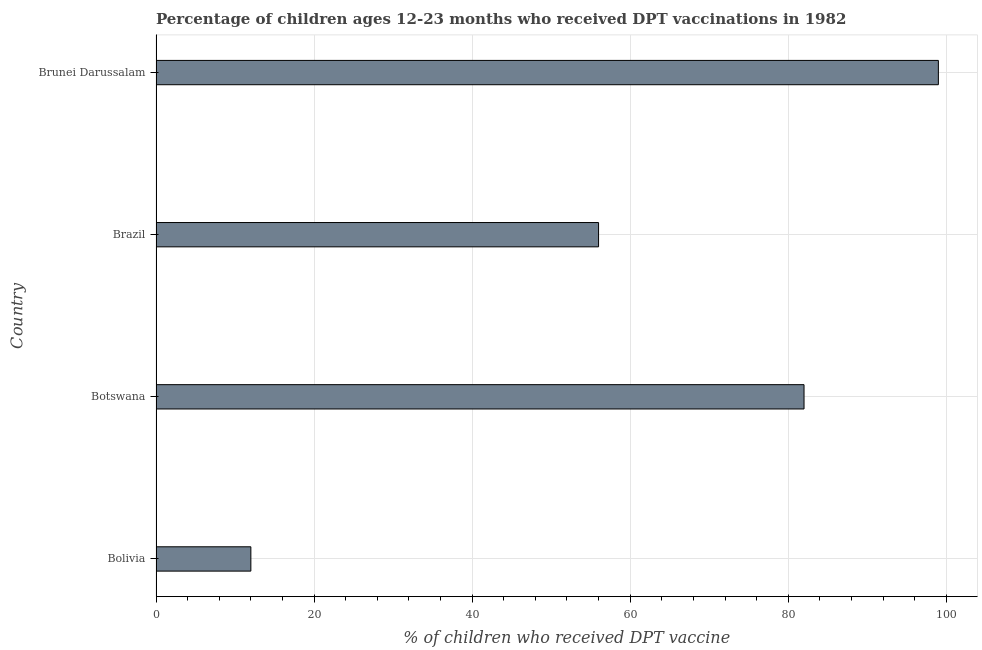What is the title of the graph?
Your response must be concise. Percentage of children ages 12-23 months who received DPT vaccinations in 1982. What is the label or title of the X-axis?
Your answer should be compact. % of children who received DPT vaccine. What is the label or title of the Y-axis?
Provide a succinct answer. Country. In which country was the percentage of children who received dpt vaccine maximum?
Give a very brief answer. Brunei Darussalam. In which country was the percentage of children who received dpt vaccine minimum?
Offer a very short reply. Bolivia. What is the sum of the percentage of children who received dpt vaccine?
Provide a short and direct response. 249. What is the average percentage of children who received dpt vaccine per country?
Keep it short and to the point. 62.25. What is the ratio of the percentage of children who received dpt vaccine in Botswana to that in Brunei Darussalam?
Offer a terse response. 0.83. Is the percentage of children who received dpt vaccine in Bolivia less than that in Brunei Darussalam?
Provide a short and direct response. Yes. Is the difference between the percentage of children who received dpt vaccine in Botswana and Brazil greater than the difference between any two countries?
Provide a succinct answer. No. Is the sum of the percentage of children who received dpt vaccine in Bolivia and Brazil greater than the maximum percentage of children who received dpt vaccine across all countries?
Your answer should be compact. No. What is the difference between the highest and the lowest percentage of children who received dpt vaccine?
Provide a short and direct response. 87. How many bars are there?
Keep it short and to the point. 4. What is the % of children who received DPT vaccine in Brazil?
Your answer should be very brief. 56. What is the difference between the % of children who received DPT vaccine in Bolivia and Botswana?
Your answer should be very brief. -70. What is the difference between the % of children who received DPT vaccine in Bolivia and Brazil?
Offer a terse response. -44. What is the difference between the % of children who received DPT vaccine in Bolivia and Brunei Darussalam?
Your response must be concise. -87. What is the difference between the % of children who received DPT vaccine in Botswana and Brazil?
Keep it short and to the point. 26. What is the difference between the % of children who received DPT vaccine in Botswana and Brunei Darussalam?
Offer a very short reply. -17. What is the difference between the % of children who received DPT vaccine in Brazil and Brunei Darussalam?
Offer a very short reply. -43. What is the ratio of the % of children who received DPT vaccine in Bolivia to that in Botswana?
Offer a very short reply. 0.15. What is the ratio of the % of children who received DPT vaccine in Bolivia to that in Brazil?
Give a very brief answer. 0.21. What is the ratio of the % of children who received DPT vaccine in Bolivia to that in Brunei Darussalam?
Your response must be concise. 0.12. What is the ratio of the % of children who received DPT vaccine in Botswana to that in Brazil?
Keep it short and to the point. 1.46. What is the ratio of the % of children who received DPT vaccine in Botswana to that in Brunei Darussalam?
Offer a very short reply. 0.83. What is the ratio of the % of children who received DPT vaccine in Brazil to that in Brunei Darussalam?
Your response must be concise. 0.57. 